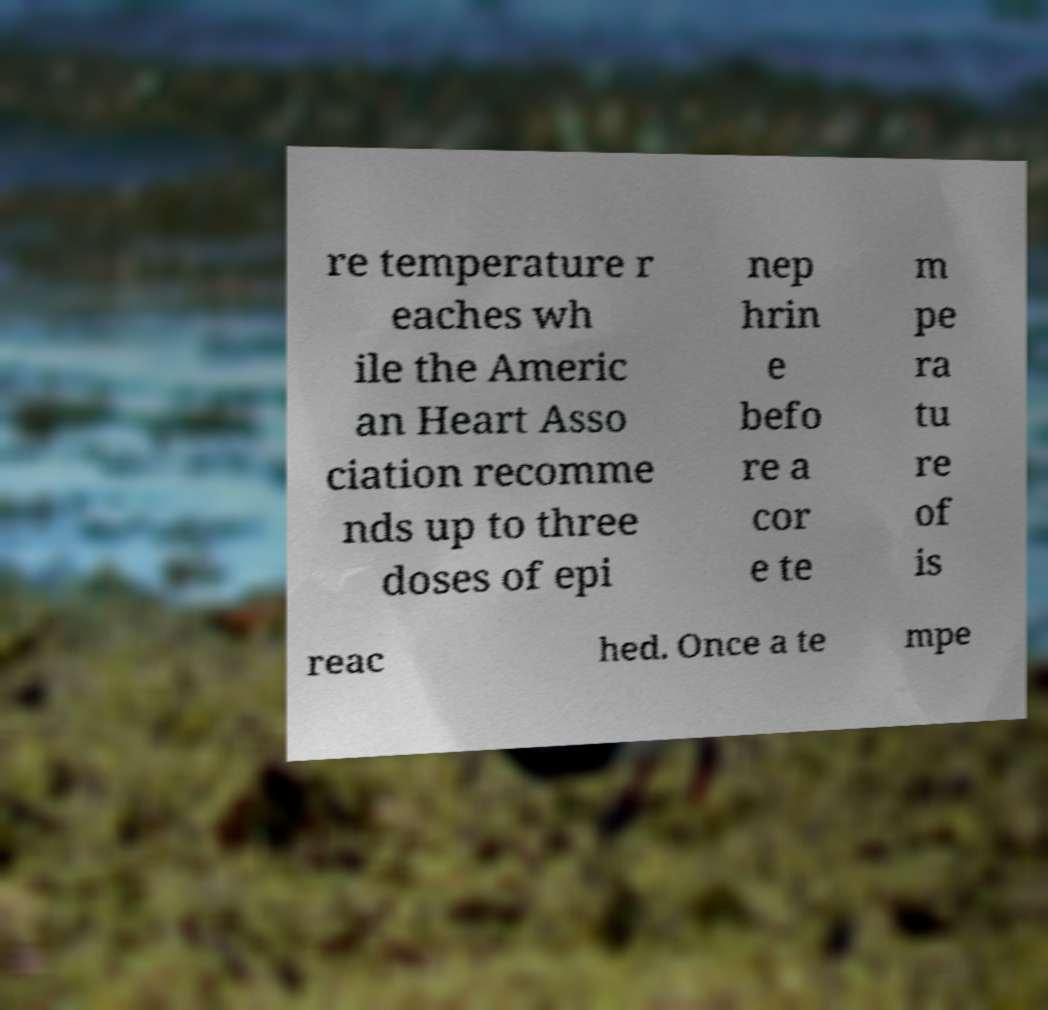Can you read and provide the text displayed in the image?This photo seems to have some interesting text. Can you extract and type it out for me? re temperature r eaches wh ile the Americ an Heart Asso ciation recomme nds up to three doses of epi nep hrin e befo re a cor e te m pe ra tu re of is reac hed. Once a te mpe 